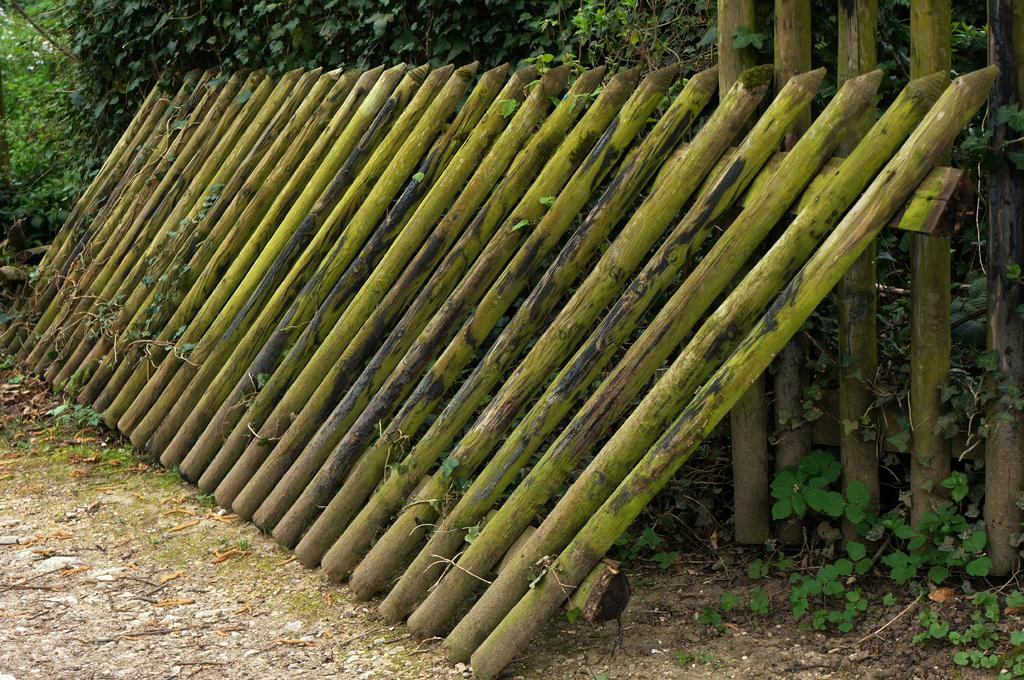What objects are located in the middle of the image? There are sticks in the middle of the image. What type of vegetation can be seen at the top of the image? There are trees at the top of the image. What type of fiction is being balanced on the adjustment in the image? There is no fiction, balance, or adjustment present in the image; it only features sticks and trees. 